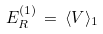<formula> <loc_0><loc_0><loc_500><loc_500>E _ { R } ^ { ( 1 ) } \, = \, \langle V \rangle _ { 1 }</formula> 